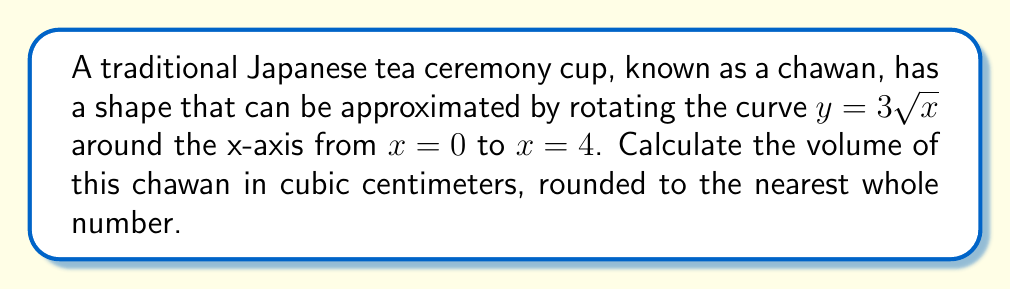Solve this math problem. To find the volume of the chawan, we need to use the volume of revolution formula. Since we're rotating around the x-axis, we'll use the disk method:

$$V = \pi \int_a^b [f(x)]^2 dx$$

Where $f(x) = 3\sqrt{x}$, $a = 0$, and $b = 4$.

Let's solve this step-by-step:

1) Substitute the function and limits into the formula:
   $$V = \pi \int_0^4 (3\sqrt{x})^2 dx$$

2) Simplify the integrand:
   $$V = \pi \int_0^4 9x dx$$

3) Integrate:
   $$V = \pi [9\frac{x^2}{2}]_0^4$$

4) Evaluate the integral:
   $$V = \pi (9\frac{4^2}{2} - 9\frac{0^2}{2})$$
   $$V = \pi (9\frac{16}{2} - 0)$$
   $$V = \pi (72)$$

5) Calculate the final value:
   $$V = 72\pi \approx 226.19 \text{ cm}^3$$

6) Round to the nearest whole number:
   $$V \approx 226 \text{ cm}^3$$

This volume represents the approximate capacity of the chawan used in traditional Japanese tea ceremonies.
Answer: 226 cm³ 